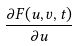<formula> <loc_0><loc_0><loc_500><loc_500>\frac { \partial F ( u , v , t ) } { \partial u }</formula> 